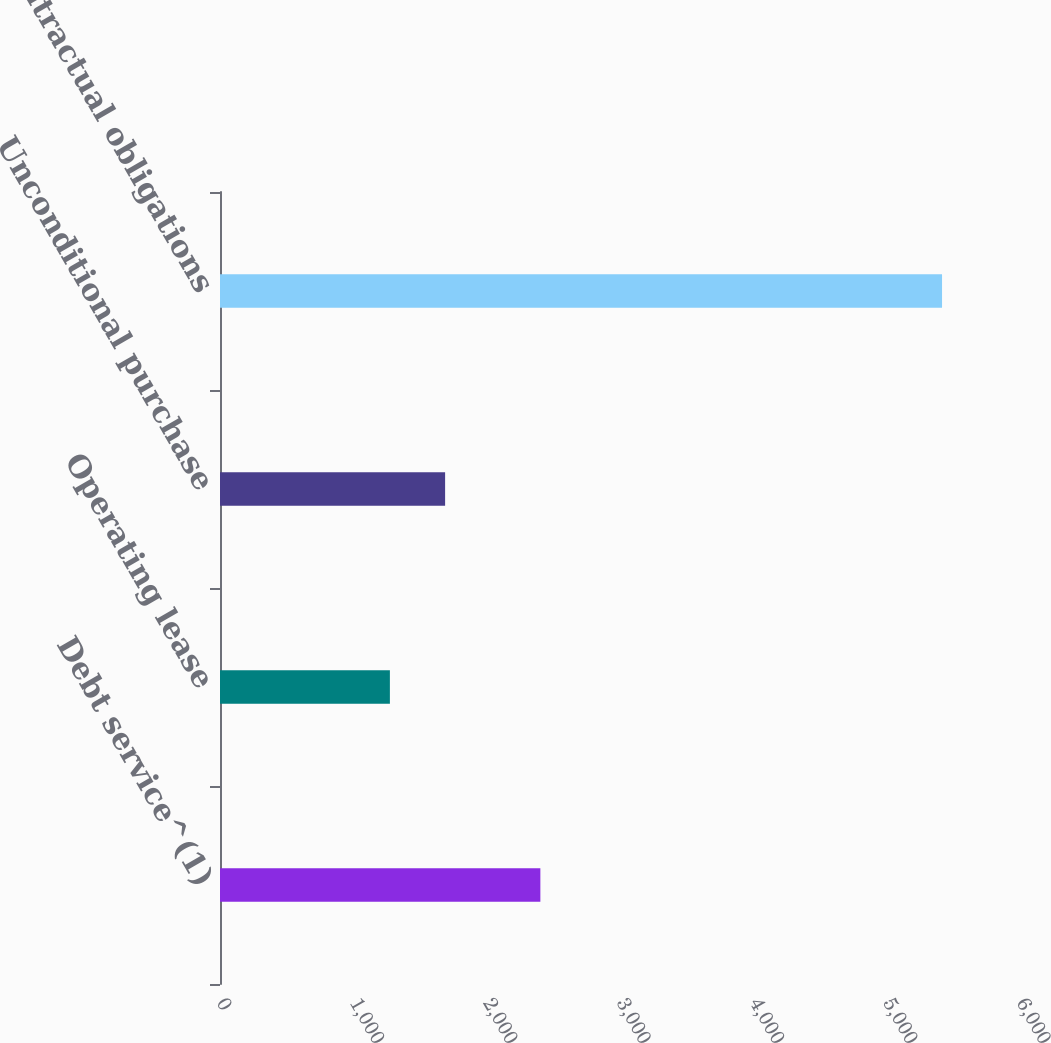Convert chart. <chart><loc_0><loc_0><loc_500><loc_500><bar_chart><fcel>Debt service^(1)<fcel>Operating lease<fcel>Unconditional purchase<fcel>Total contractual obligations<nl><fcel>2402.7<fcel>1274.2<fcel>1688.31<fcel>5415.3<nl></chart> 